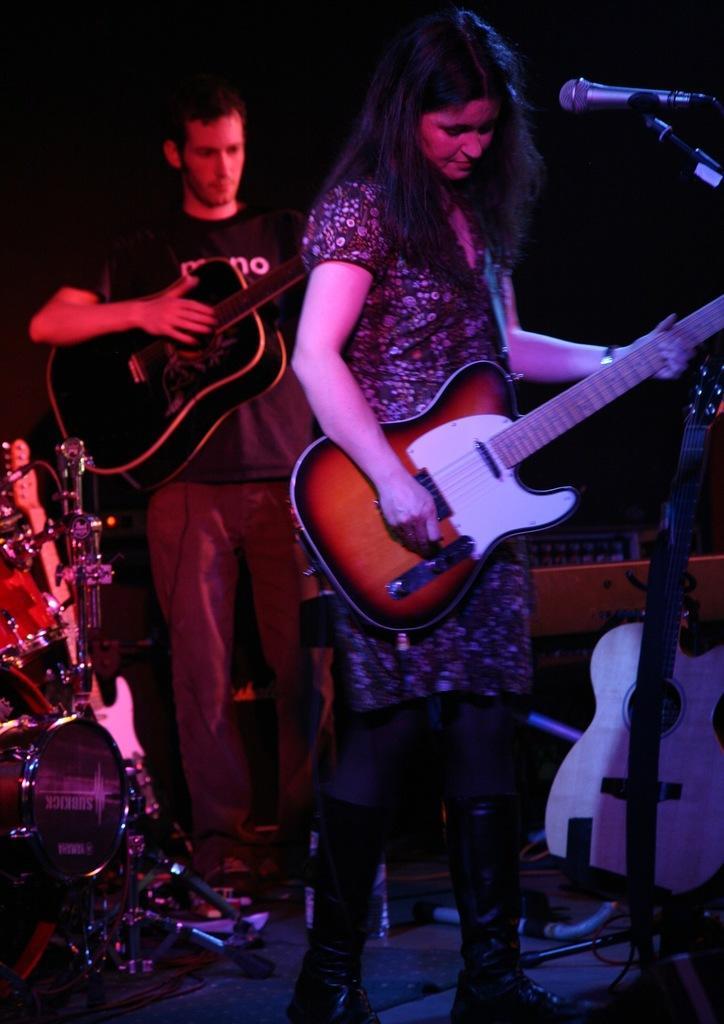Can you describe this image briefly? In this image I can see a man and a woman are standing. I can see both of them are holding guitars. I can also see a mic and few more musical instruments. 